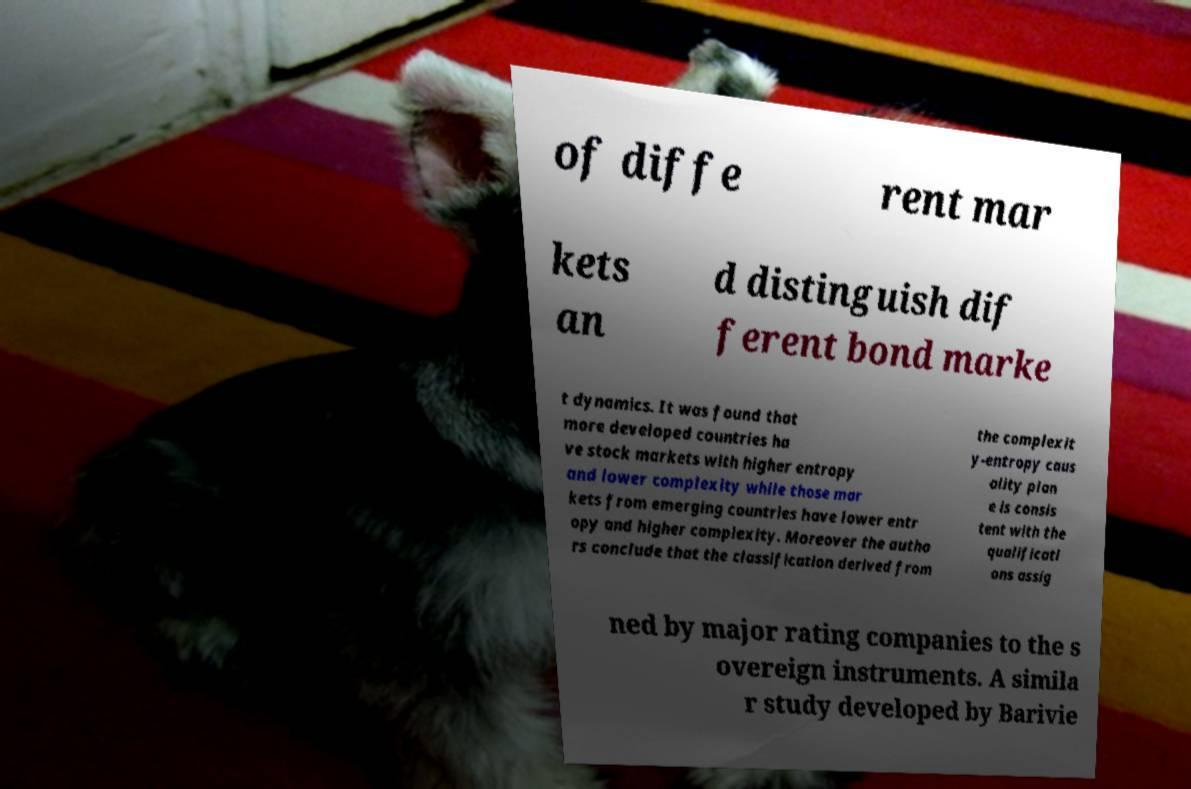Could you assist in decoding the text presented in this image and type it out clearly? of diffe rent mar kets an d distinguish dif ferent bond marke t dynamics. It was found that more developed countries ha ve stock markets with higher entropy and lower complexity while those mar kets from emerging countries have lower entr opy and higher complexity. Moreover the autho rs conclude that the classification derived from the complexit y-entropy caus ality plan e is consis tent with the qualificati ons assig ned by major rating companies to the s overeign instruments. A simila r study developed by Barivie 